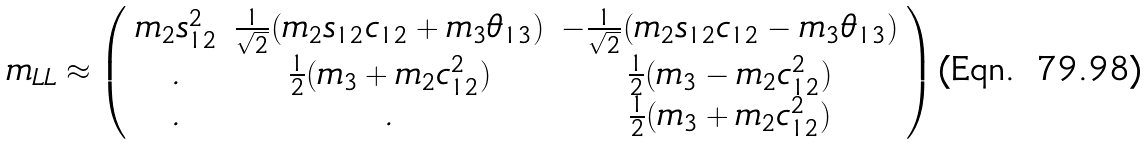Convert formula to latex. <formula><loc_0><loc_0><loc_500><loc_500>m _ { L L } \approx \left ( \begin{array} { c c c } m _ { 2 } s _ { 1 2 } ^ { 2 } & \frac { 1 } { \sqrt { 2 } } ( m _ { 2 } s _ { 1 2 } c _ { 1 2 } + m _ { 3 } \theta _ { 1 3 } ) & - \frac { 1 } { \sqrt { 2 } } ( m _ { 2 } s _ { 1 2 } c _ { 1 2 } - m _ { 3 } \theta _ { 1 3 } ) \\ . & \frac { 1 } { 2 } ( m _ { 3 } + m _ { 2 } c ^ { 2 } _ { 1 2 } ) & \frac { 1 } { 2 } ( m _ { 3 } - m _ { 2 } c ^ { 2 } _ { 1 2 } ) \\ . & . & \frac { 1 } { 2 } ( m _ { 3 } + m _ { 2 } c ^ { 2 } _ { 1 2 } ) \end{array} \right )</formula> 